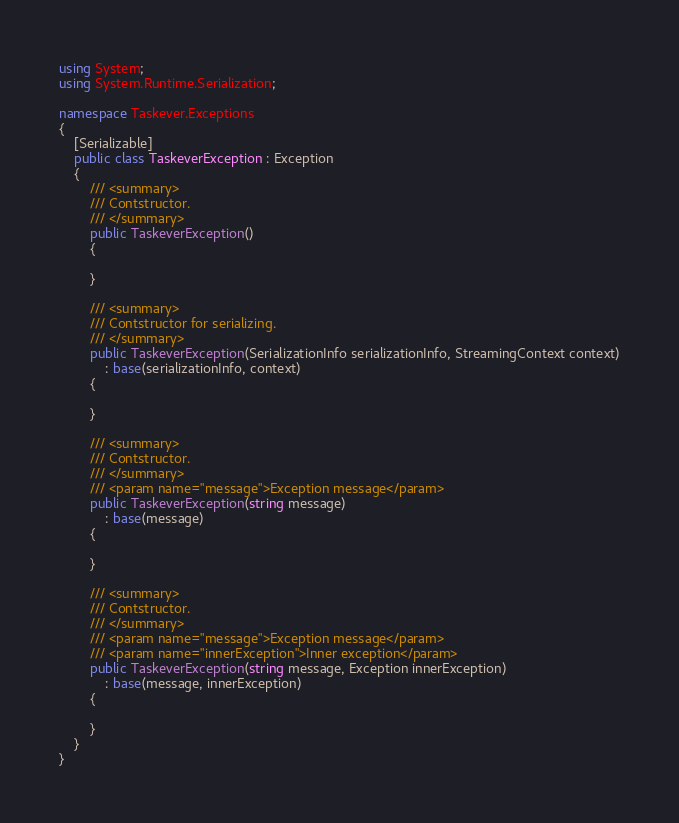Convert code to text. <code><loc_0><loc_0><loc_500><loc_500><_C#_>using System;
using System.Runtime.Serialization;

namespace Taskever.Exceptions
{
    [Serializable]
    public class TaskeverException : Exception
    {
        /// <summary>
        /// Contstructor.
        /// </summary>
        public TaskeverException()
        {

        }

        /// <summary>
        /// Contstructor for serializing.
        /// </summary>
        public TaskeverException(SerializationInfo serializationInfo, StreamingContext context)
            : base(serializationInfo, context)
        {

        }

        /// <summary>
        /// Contstructor.
        /// </summary>
        /// <param name="message">Exception message</param>
        public TaskeverException(string message)
            : base(message)
        {

        }

        /// <summary>
        /// Contstructor.
        /// </summary>
        /// <param name="message">Exception message</param>
        /// <param name="innerException">Inner exception</param>
        public TaskeverException(string message, Exception innerException)
            : base(message, innerException)
        {

        }
    }
}</code> 